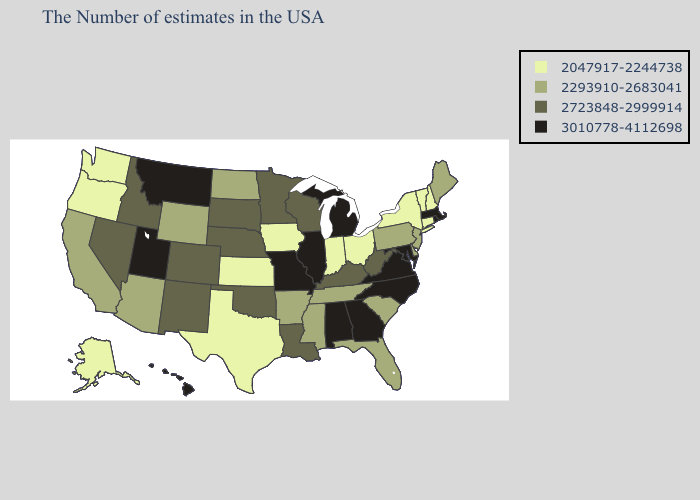What is the lowest value in states that border Utah?
Write a very short answer. 2293910-2683041. What is the highest value in states that border Tennessee?
Concise answer only. 3010778-4112698. Name the states that have a value in the range 2047917-2244738?
Short answer required. New Hampshire, Vermont, Connecticut, New York, Ohio, Indiana, Iowa, Kansas, Texas, Washington, Oregon, Alaska. Does North Carolina have a lower value than Nebraska?
Answer briefly. No. Among the states that border New Mexico , which have the lowest value?
Keep it brief. Texas. How many symbols are there in the legend?
Keep it brief. 4. What is the value of New York?
Answer briefly. 2047917-2244738. Which states have the highest value in the USA?
Short answer required. Massachusetts, Rhode Island, Maryland, Virginia, North Carolina, Georgia, Michigan, Alabama, Illinois, Missouri, Utah, Montana, Hawaii. Does Indiana have a lower value than Kansas?
Be succinct. No. What is the lowest value in the USA?
Be succinct. 2047917-2244738. Among the states that border Arkansas , does Texas have the lowest value?
Keep it brief. Yes. Among the states that border Missouri , does Illinois have the highest value?
Answer briefly. Yes. Is the legend a continuous bar?
Be succinct. No. What is the lowest value in states that border Minnesota?
Answer briefly. 2047917-2244738. Name the states that have a value in the range 2047917-2244738?
Keep it brief. New Hampshire, Vermont, Connecticut, New York, Ohio, Indiana, Iowa, Kansas, Texas, Washington, Oregon, Alaska. 